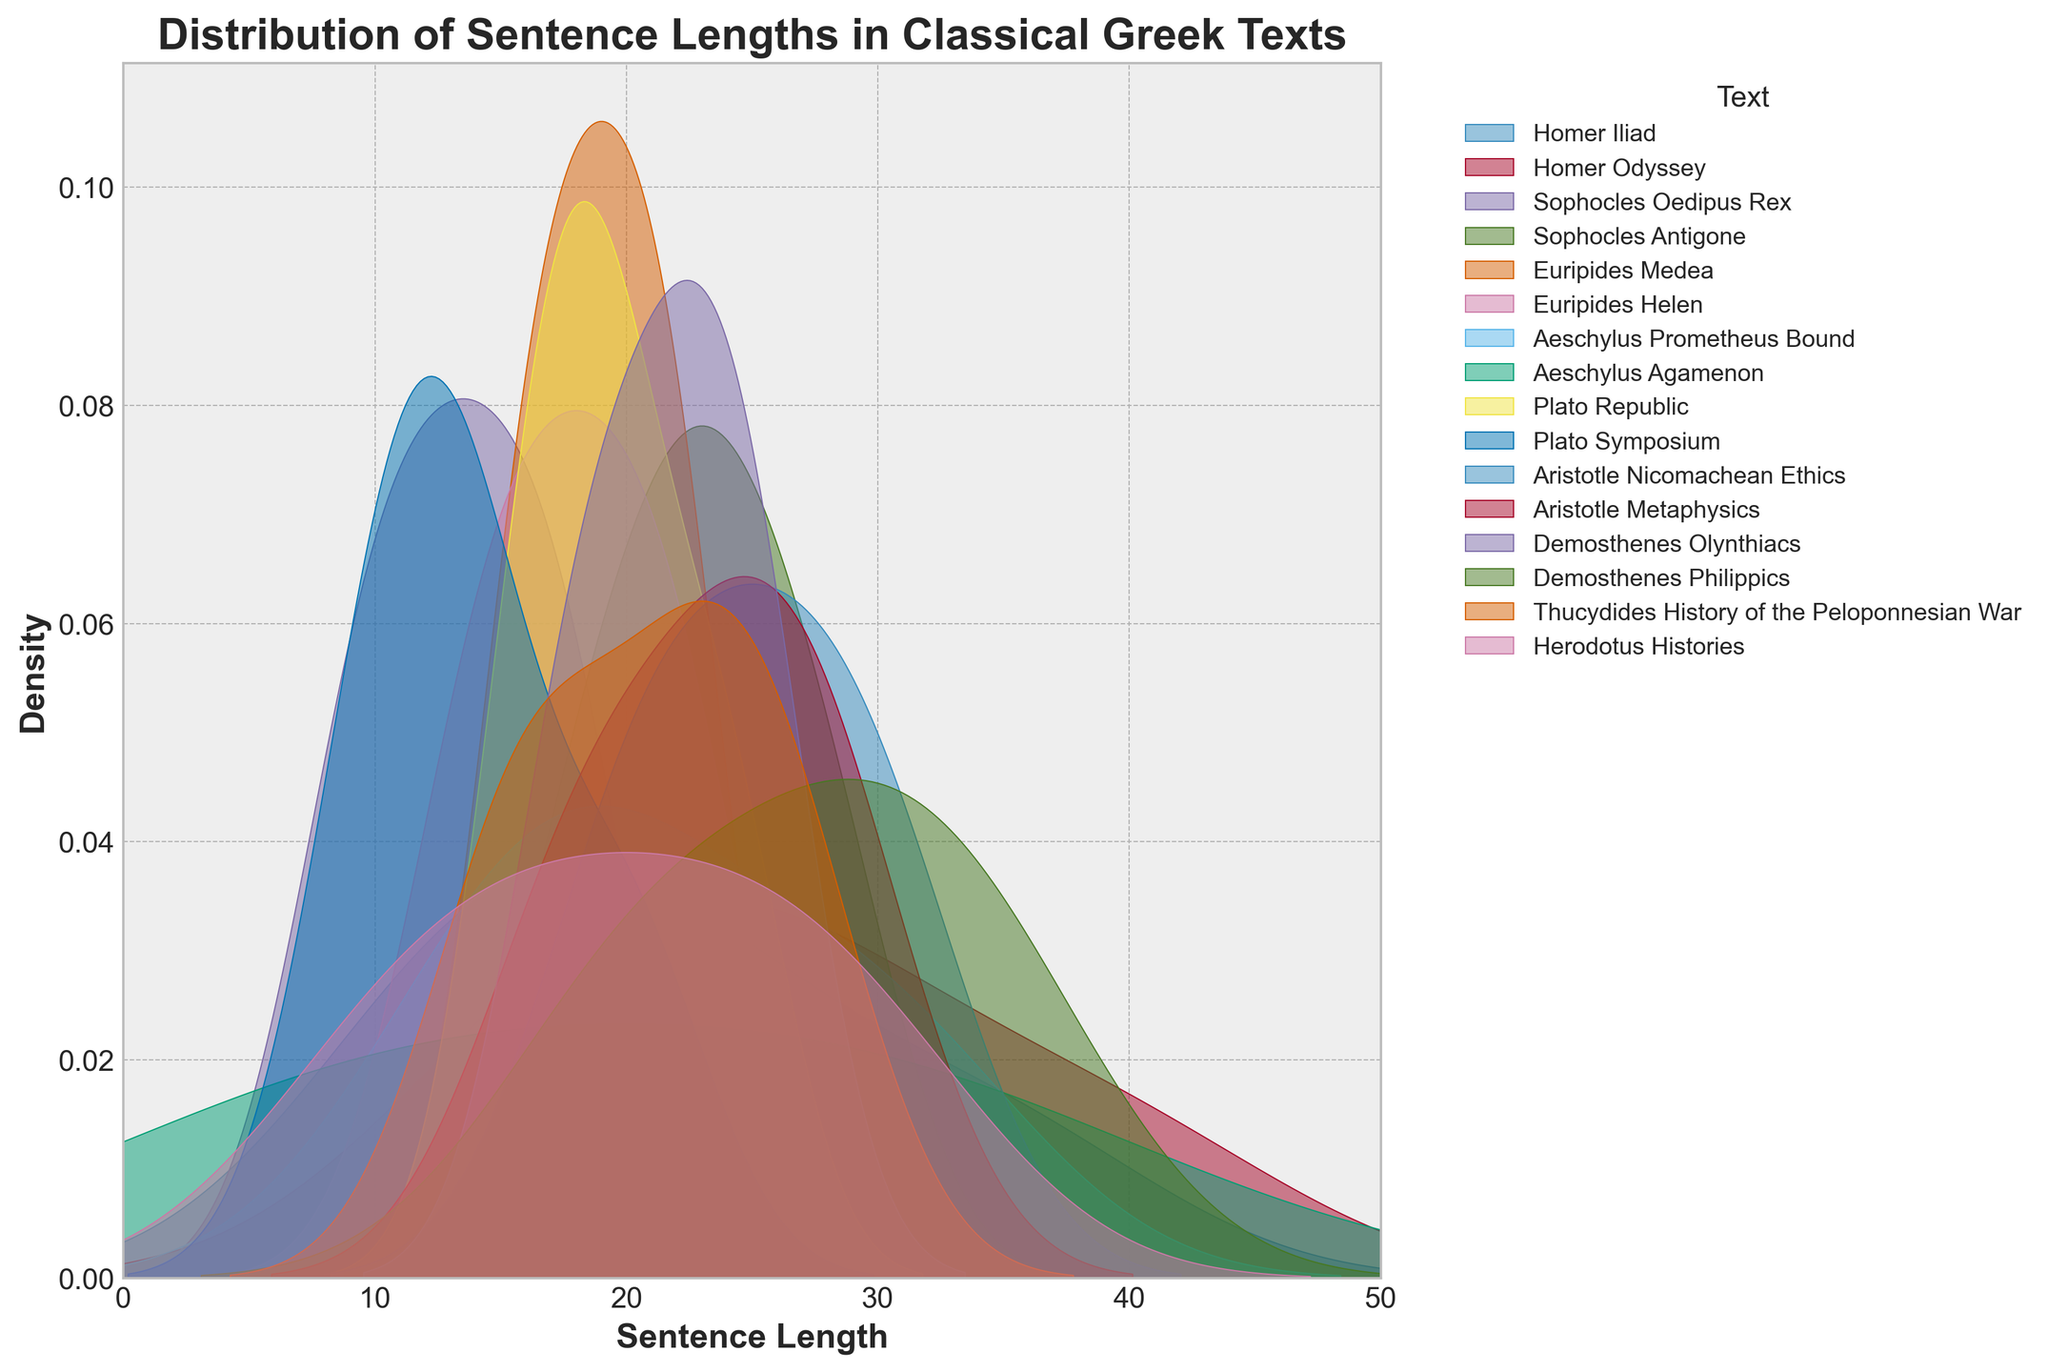What is the title of the figure? The title of the figure is found at the top of the plot and it describes the main subject of the visualization.
Answer: Distribution of Sentence Lengths in Classical Greek Texts Which text has the densest peak around a sentence length of 20? Look for the KDE plot line that peaks highest around the 20 mark on the x-axis.
Answer: Herodotus Histories What is the x-axis label? The x-axis label typically describes what is being measured along the horizontal axis.
Answer: Sentence Length Which text has a density curve peaking at the shortest sentence length? Identify the KDE plot line that reaches the highest density at the smallest value on the x-axis.
Answer: Sophocles Oedipus Rex Compare the sentence length distributions of Plato Symposium and Aristotle Nicomachean Ethics. Where is the peak in each distribution? Observe and describe where the highest points (peaks) occur in the KDE plots for both texts. Plato Symposium peaks around 14 and Aristotle Nicomachean Ethics peaks around 25.
Answer: Plato Symposium at 14, Aristotle Nicomachean Ethics at 25 How does the distribution of sentence lengths differ between Homer Odyssey and Demosthenes Philippics? Compare the shapes, peak locations, and spread of the KDE curves for both texts. Homer Odyssey has a peak around 25 and a broader spread, while Demosthenes Philippics has a peak around 34 with a relatively narrower spread.
Answer: Homer Odyssey peaks at 25, Demosthenes Philippics peaks at 34 Which text shows the greatest variability in sentence lengths? Look at the KDE plots to identify which text has a wide, flat distribution, indicating high variability.
Answer: Homer Odyssey Is there any text that has a noticeable bimodal distribution in sentence lengths? Observe the KDE plots to see if any of them have two distinct peaks, which would indicate a bimodal distribution.
Answer: Herodotus Histories Which texts have peaks above a sentence length of 30? Check if any KDE plots reach their highest density at a sentence length greater than 30.
Answer: Demosthenes Philippics and Aeschylus Prometheus Bound 